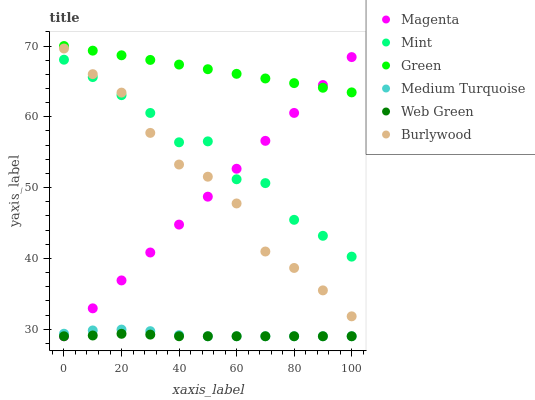Does Web Green have the minimum area under the curve?
Answer yes or no. Yes. Does Green have the maximum area under the curve?
Answer yes or no. Yes. Does Green have the minimum area under the curve?
Answer yes or no. No. Does Web Green have the maximum area under the curve?
Answer yes or no. No. Is Green the smoothest?
Answer yes or no. Yes. Is Mint the roughest?
Answer yes or no. Yes. Is Web Green the smoothest?
Answer yes or no. No. Is Web Green the roughest?
Answer yes or no. No. Does Web Green have the lowest value?
Answer yes or no. Yes. Does Green have the lowest value?
Answer yes or no. No. Does Green have the highest value?
Answer yes or no. Yes. Does Web Green have the highest value?
Answer yes or no. No. Is Medium Turquoise less than Mint?
Answer yes or no. Yes. Is Burlywood greater than Web Green?
Answer yes or no. Yes. Does Mint intersect Magenta?
Answer yes or no. Yes. Is Mint less than Magenta?
Answer yes or no. No. Is Mint greater than Magenta?
Answer yes or no. No. Does Medium Turquoise intersect Mint?
Answer yes or no. No. 